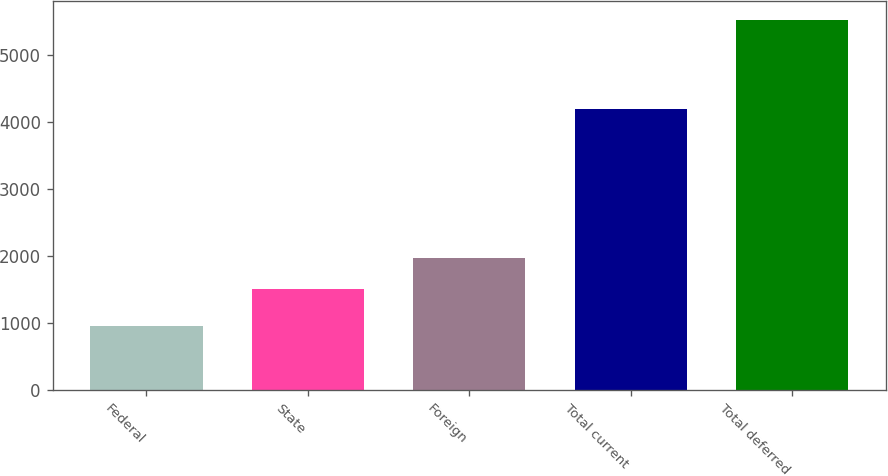Convert chart. <chart><loc_0><loc_0><loc_500><loc_500><bar_chart><fcel>Federal<fcel>State<fcel>Foreign<fcel>Total current<fcel>Total deferred<nl><fcel>949<fcel>1504<fcel>1961.4<fcel>4190<fcel>5523<nl></chart> 